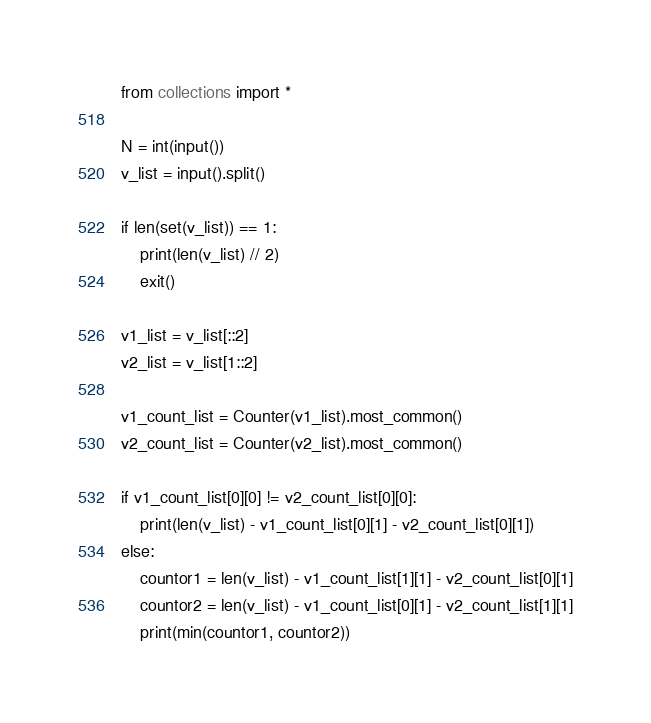Convert code to text. <code><loc_0><loc_0><loc_500><loc_500><_Python_>from collections import *

N = int(input())
v_list = input().split()

if len(set(v_list)) == 1:
    print(len(v_list) // 2)
    exit()

v1_list = v_list[::2]
v2_list = v_list[1::2]

v1_count_list = Counter(v1_list).most_common()
v2_count_list = Counter(v2_list).most_common()

if v1_count_list[0][0] != v2_count_list[0][0]:
    print(len(v_list) - v1_count_list[0][1] - v2_count_list[0][1])
else:
    countor1 = len(v_list) - v1_count_list[1][1] - v2_count_list[0][1]
    countor2 = len(v_list) - v1_count_list[0][1] - v2_count_list[1][1]
    print(min(countor1, countor2))</code> 